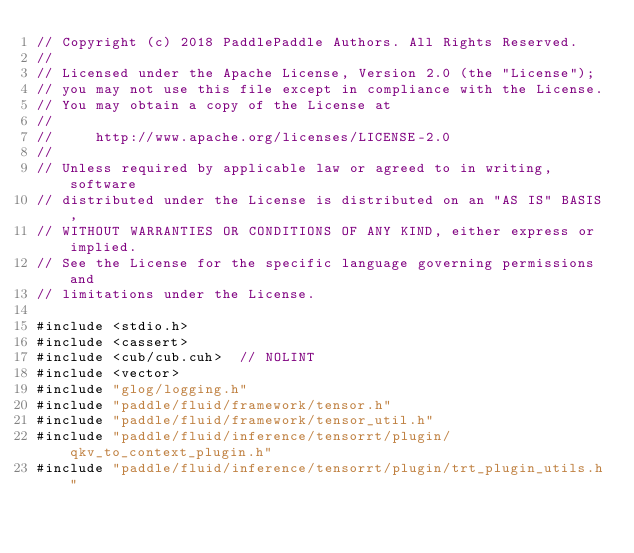<code> <loc_0><loc_0><loc_500><loc_500><_Cuda_>// Copyright (c) 2018 PaddlePaddle Authors. All Rights Reserved.
//
// Licensed under the Apache License, Version 2.0 (the "License");
// you may not use this file except in compliance with the License.
// You may obtain a copy of the License at
//
//     http://www.apache.org/licenses/LICENSE-2.0
//
// Unless required by applicable law or agreed to in writing, software
// distributed under the License is distributed on an "AS IS" BASIS,
// WITHOUT WARRANTIES OR CONDITIONS OF ANY KIND, either express or implied.
// See the License for the specific language governing permissions and
// limitations under the License.

#include <stdio.h>
#include <cassert>
#include <cub/cub.cuh>  // NOLINT
#include <vector>
#include "glog/logging.h"
#include "paddle/fluid/framework/tensor.h"
#include "paddle/fluid/framework/tensor_util.h"
#include "paddle/fluid/inference/tensorrt/plugin/qkv_to_context_plugin.h"
#include "paddle/fluid/inference/tensorrt/plugin/trt_plugin_utils.h"</code> 